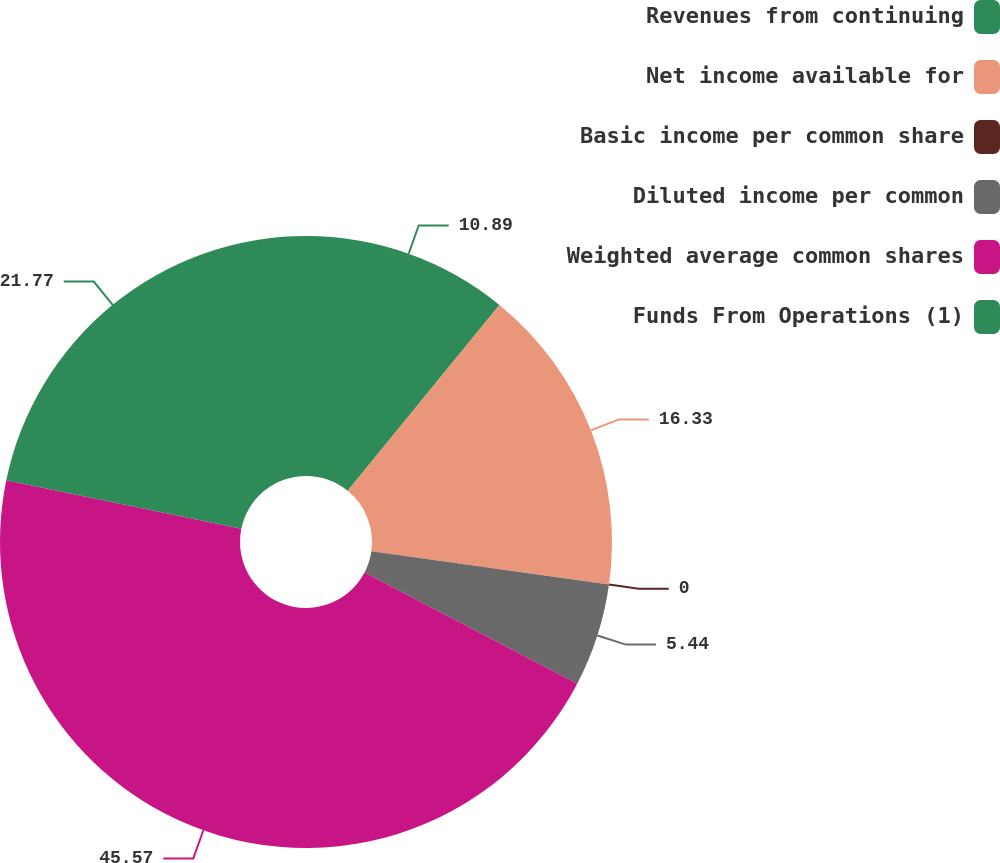Convert chart. <chart><loc_0><loc_0><loc_500><loc_500><pie_chart><fcel>Revenues from continuing<fcel>Net income available for<fcel>Basic income per common share<fcel>Diluted income per common<fcel>Weighted average common shares<fcel>Funds From Operations (1)<nl><fcel>10.89%<fcel>16.33%<fcel>0.0%<fcel>5.44%<fcel>45.57%<fcel>21.77%<nl></chart> 